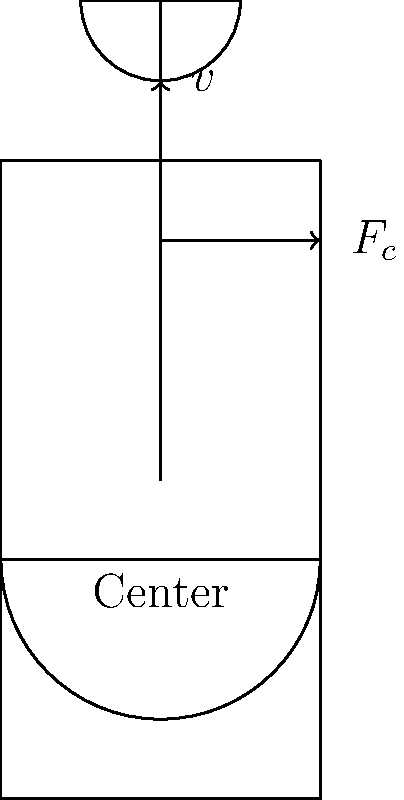In the diagram of a stand mixer, the centripetal force $F_c$ is shown acting on the mixer blade. If the blade is rotating at a constant angular velocity $\omega$, how would the magnitude of $F_c$ change if the radius of rotation were doubled, assuming all other factors remain constant? Let's approach this step-by-step:

1) The centripetal force $F_c$ is given by the equation:

   $$F_c = m\omega^2r$$

   where $m$ is the mass of the object, $\omega$ is the angular velocity, and $r$ is the radius of rotation.

2) We're told that the angular velocity $\omega$ remains constant, and we can assume the mass $m$ of the blade doesn't change.

3) The question states that the radius $r$ is doubled. Let's call the new radius $r'$, so:

   $$r' = 2r$$

4) Now, let's calculate the new centripetal force $F_c'$:

   $$F_c' = m\omega^2r'$$
   $$F_c' = m\omega^2(2r)$$
   $$F_c' = 2m\omega^2r$$

5) Comparing this to the original force:

   $$F_c' = 2m\omega^2r = 2F_c$$

6) Therefore, doubling the radius results in doubling the centripetal force.
Answer: The centripetal force would double. 